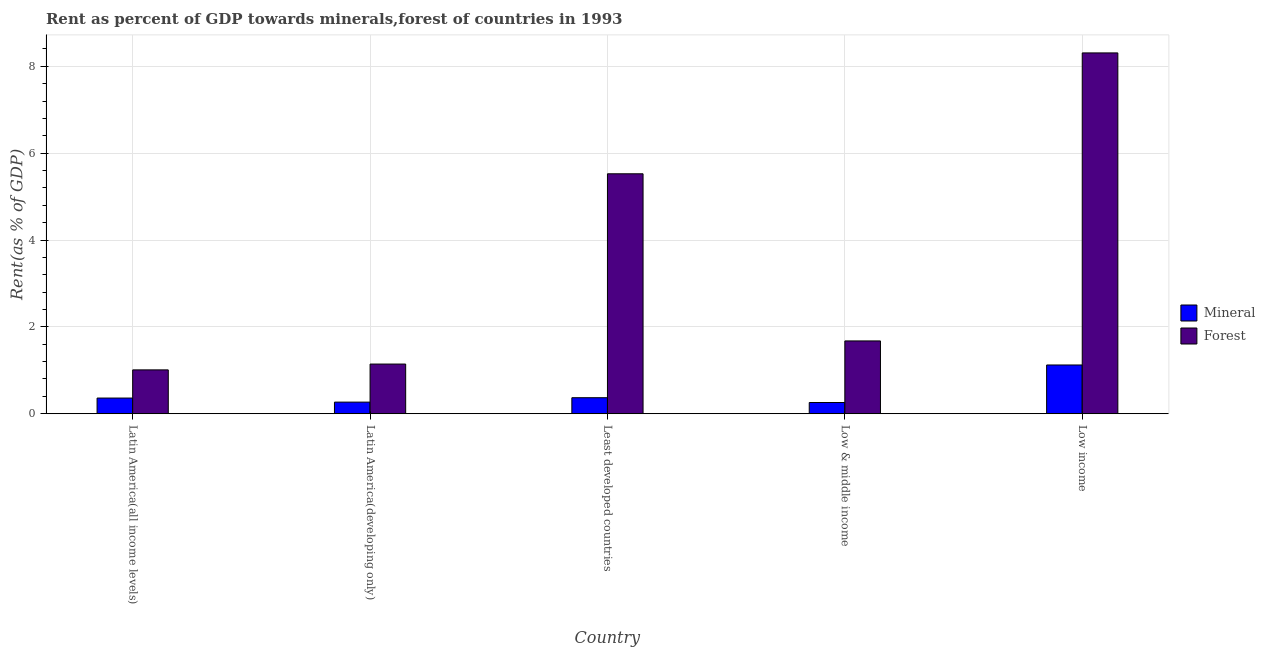How many different coloured bars are there?
Your answer should be very brief. 2. How many groups of bars are there?
Ensure brevity in your answer.  5. Are the number of bars on each tick of the X-axis equal?
Give a very brief answer. Yes. How many bars are there on the 1st tick from the left?
Your response must be concise. 2. How many bars are there on the 5th tick from the right?
Keep it short and to the point. 2. What is the label of the 3rd group of bars from the left?
Give a very brief answer. Least developed countries. In how many cases, is the number of bars for a given country not equal to the number of legend labels?
Provide a succinct answer. 0. What is the forest rent in Latin America(developing only)?
Your response must be concise. 1.14. Across all countries, what is the maximum mineral rent?
Provide a succinct answer. 1.12. Across all countries, what is the minimum forest rent?
Provide a short and direct response. 1.01. In which country was the forest rent minimum?
Provide a short and direct response. Latin America(all income levels). What is the total forest rent in the graph?
Provide a short and direct response. 17.66. What is the difference between the mineral rent in Latin America(all income levels) and that in Low & middle income?
Give a very brief answer. 0.1. What is the difference between the forest rent in Latin America(developing only) and the mineral rent in Low & middle income?
Provide a succinct answer. 0.89. What is the average forest rent per country?
Your response must be concise. 3.53. What is the difference between the forest rent and mineral rent in Low income?
Provide a succinct answer. 7.18. In how many countries, is the mineral rent greater than 0.4 %?
Provide a succinct answer. 1. What is the ratio of the forest rent in Latin America(all income levels) to that in Low & middle income?
Provide a short and direct response. 0.6. What is the difference between the highest and the second highest forest rent?
Your answer should be compact. 2.78. What is the difference between the highest and the lowest mineral rent?
Give a very brief answer. 0.86. In how many countries, is the mineral rent greater than the average mineral rent taken over all countries?
Make the answer very short. 1. Is the sum of the forest rent in Latin America(developing only) and Least developed countries greater than the maximum mineral rent across all countries?
Provide a short and direct response. Yes. What does the 2nd bar from the left in Least developed countries represents?
Your response must be concise. Forest. What does the 1st bar from the right in Low income represents?
Your response must be concise. Forest. How many countries are there in the graph?
Offer a very short reply. 5. Are the values on the major ticks of Y-axis written in scientific E-notation?
Your response must be concise. No. Does the graph contain any zero values?
Your response must be concise. No. Does the graph contain grids?
Keep it short and to the point. Yes. How many legend labels are there?
Keep it short and to the point. 2. What is the title of the graph?
Keep it short and to the point. Rent as percent of GDP towards minerals,forest of countries in 1993. Does "Stunting" appear as one of the legend labels in the graph?
Ensure brevity in your answer.  No. What is the label or title of the Y-axis?
Provide a short and direct response. Rent(as % of GDP). What is the Rent(as % of GDP) of Mineral in Latin America(all income levels)?
Offer a very short reply. 0.36. What is the Rent(as % of GDP) of Forest in Latin America(all income levels)?
Ensure brevity in your answer.  1.01. What is the Rent(as % of GDP) of Mineral in Latin America(developing only)?
Provide a short and direct response. 0.27. What is the Rent(as % of GDP) in Forest in Latin America(developing only)?
Offer a terse response. 1.14. What is the Rent(as % of GDP) in Mineral in Least developed countries?
Give a very brief answer. 0.37. What is the Rent(as % of GDP) of Forest in Least developed countries?
Offer a very short reply. 5.52. What is the Rent(as % of GDP) in Mineral in Low & middle income?
Give a very brief answer. 0.26. What is the Rent(as % of GDP) of Forest in Low & middle income?
Offer a very short reply. 1.68. What is the Rent(as % of GDP) in Mineral in Low income?
Offer a terse response. 1.12. What is the Rent(as % of GDP) in Forest in Low income?
Offer a very short reply. 8.31. Across all countries, what is the maximum Rent(as % of GDP) of Mineral?
Offer a very short reply. 1.12. Across all countries, what is the maximum Rent(as % of GDP) of Forest?
Keep it short and to the point. 8.31. Across all countries, what is the minimum Rent(as % of GDP) in Mineral?
Your answer should be very brief. 0.26. Across all countries, what is the minimum Rent(as % of GDP) in Forest?
Your answer should be very brief. 1.01. What is the total Rent(as % of GDP) in Mineral in the graph?
Ensure brevity in your answer.  2.38. What is the total Rent(as % of GDP) in Forest in the graph?
Provide a succinct answer. 17.66. What is the difference between the Rent(as % of GDP) in Mineral in Latin America(all income levels) and that in Latin America(developing only)?
Your answer should be very brief. 0.09. What is the difference between the Rent(as % of GDP) of Forest in Latin America(all income levels) and that in Latin America(developing only)?
Give a very brief answer. -0.13. What is the difference between the Rent(as % of GDP) in Mineral in Latin America(all income levels) and that in Least developed countries?
Keep it short and to the point. -0.01. What is the difference between the Rent(as % of GDP) of Forest in Latin America(all income levels) and that in Least developed countries?
Provide a succinct answer. -4.51. What is the difference between the Rent(as % of GDP) of Mineral in Latin America(all income levels) and that in Low & middle income?
Ensure brevity in your answer.  0.1. What is the difference between the Rent(as % of GDP) in Forest in Latin America(all income levels) and that in Low & middle income?
Ensure brevity in your answer.  -0.67. What is the difference between the Rent(as % of GDP) of Mineral in Latin America(all income levels) and that in Low income?
Offer a very short reply. -0.76. What is the difference between the Rent(as % of GDP) of Forest in Latin America(all income levels) and that in Low income?
Your answer should be very brief. -7.3. What is the difference between the Rent(as % of GDP) of Mineral in Latin America(developing only) and that in Least developed countries?
Provide a short and direct response. -0.1. What is the difference between the Rent(as % of GDP) in Forest in Latin America(developing only) and that in Least developed countries?
Keep it short and to the point. -4.38. What is the difference between the Rent(as % of GDP) in Mineral in Latin America(developing only) and that in Low & middle income?
Your response must be concise. 0.01. What is the difference between the Rent(as % of GDP) in Forest in Latin America(developing only) and that in Low & middle income?
Offer a very short reply. -0.53. What is the difference between the Rent(as % of GDP) of Mineral in Latin America(developing only) and that in Low income?
Your answer should be very brief. -0.86. What is the difference between the Rent(as % of GDP) of Forest in Latin America(developing only) and that in Low income?
Give a very brief answer. -7.16. What is the difference between the Rent(as % of GDP) of Mineral in Least developed countries and that in Low & middle income?
Offer a terse response. 0.11. What is the difference between the Rent(as % of GDP) of Forest in Least developed countries and that in Low & middle income?
Ensure brevity in your answer.  3.85. What is the difference between the Rent(as % of GDP) in Mineral in Least developed countries and that in Low income?
Ensure brevity in your answer.  -0.75. What is the difference between the Rent(as % of GDP) of Forest in Least developed countries and that in Low income?
Offer a terse response. -2.78. What is the difference between the Rent(as % of GDP) of Mineral in Low & middle income and that in Low income?
Make the answer very short. -0.86. What is the difference between the Rent(as % of GDP) in Forest in Low & middle income and that in Low income?
Provide a succinct answer. -6.63. What is the difference between the Rent(as % of GDP) in Mineral in Latin America(all income levels) and the Rent(as % of GDP) in Forest in Latin America(developing only)?
Offer a very short reply. -0.78. What is the difference between the Rent(as % of GDP) of Mineral in Latin America(all income levels) and the Rent(as % of GDP) of Forest in Least developed countries?
Keep it short and to the point. -5.16. What is the difference between the Rent(as % of GDP) in Mineral in Latin America(all income levels) and the Rent(as % of GDP) in Forest in Low & middle income?
Your answer should be compact. -1.32. What is the difference between the Rent(as % of GDP) in Mineral in Latin America(all income levels) and the Rent(as % of GDP) in Forest in Low income?
Your answer should be compact. -7.95. What is the difference between the Rent(as % of GDP) of Mineral in Latin America(developing only) and the Rent(as % of GDP) of Forest in Least developed countries?
Your response must be concise. -5.26. What is the difference between the Rent(as % of GDP) in Mineral in Latin America(developing only) and the Rent(as % of GDP) in Forest in Low & middle income?
Make the answer very short. -1.41. What is the difference between the Rent(as % of GDP) of Mineral in Latin America(developing only) and the Rent(as % of GDP) of Forest in Low income?
Offer a very short reply. -8.04. What is the difference between the Rent(as % of GDP) in Mineral in Least developed countries and the Rent(as % of GDP) in Forest in Low & middle income?
Offer a very short reply. -1.31. What is the difference between the Rent(as % of GDP) of Mineral in Least developed countries and the Rent(as % of GDP) of Forest in Low income?
Offer a very short reply. -7.94. What is the difference between the Rent(as % of GDP) in Mineral in Low & middle income and the Rent(as % of GDP) in Forest in Low income?
Your answer should be compact. -8.05. What is the average Rent(as % of GDP) of Mineral per country?
Your response must be concise. 0.48. What is the average Rent(as % of GDP) in Forest per country?
Make the answer very short. 3.53. What is the difference between the Rent(as % of GDP) in Mineral and Rent(as % of GDP) in Forest in Latin America(all income levels)?
Your answer should be compact. -0.65. What is the difference between the Rent(as % of GDP) of Mineral and Rent(as % of GDP) of Forest in Latin America(developing only)?
Ensure brevity in your answer.  -0.88. What is the difference between the Rent(as % of GDP) in Mineral and Rent(as % of GDP) in Forest in Least developed countries?
Your answer should be compact. -5.16. What is the difference between the Rent(as % of GDP) in Mineral and Rent(as % of GDP) in Forest in Low & middle income?
Offer a terse response. -1.42. What is the difference between the Rent(as % of GDP) in Mineral and Rent(as % of GDP) in Forest in Low income?
Make the answer very short. -7.18. What is the ratio of the Rent(as % of GDP) in Mineral in Latin America(all income levels) to that in Latin America(developing only)?
Provide a succinct answer. 1.35. What is the ratio of the Rent(as % of GDP) of Forest in Latin America(all income levels) to that in Latin America(developing only)?
Ensure brevity in your answer.  0.88. What is the ratio of the Rent(as % of GDP) in Mineral in Latin America(all income levels) to that in Least developed countries?
Make the answer very short. 0.98. What is the ratio of the Rent(as % of GDP) in Forest in Latin America(all income levels) to that in Least developed countries?
Give a very brief answer. 0.18. What is the ratio of the Rent(as % of GDP) in Mineral in Latin America(all income levels) to that in Low & middle income?
Give a very brief answer. 1.4. What is the ratio of the Rent(as % of GDP) in Forest in Latin America(all income levels) to that in Low & middle income?
Offer a terse response. 0.6. What is the ratio of the Rent(as % of GDP) of Mineral in Latin America(all income levels) to that in Low income?
Your response must be concise. 0.32. What is the ratio of the Rent(as % of GDP) in Forest in Latin America(all income levels) to that in Low income?
Offer a terse response. 0.12. What is the ratio of the Rent(as % of GDP) of Mineral in Latin America(developing only) to that in Least developed countries?
Offer a very short reply. 0.72. What is the ratio of the Rent(as % of GDP) in Forest in Latin America(developing only) to that in Least developed countries?
Your answer should be compact. 0.21. What is the ratio of the Rent(as % of GDP) of Mineral in Latin America(developing only) to that in Low & middle income?
Offer a very short reply. 1.03. What is the ratio of the Rent(as % of GDP) in Forest in Latin America(developing only) to that in Low & middle income?
Provide a short and direct response. 0.68. What is the ratio of the Rent(as % of GDP) in Mineral in Latin America(developing only) to that in Low income?
Provide a short and direct response. 0.24. What is the ratio of the Rent(as % of GDP) in Forest in Latin America(developing only) to that in Low income?
Your response must be concise. 0.14. What is the ratio of the Rent(as % of GDP) of Mineral in Least developed countries to that in Low & middle income?
Give a very brief answer. 1.43. What is the ratio of the Rent(as % of GDP) of Forest in Least developed countries to that in Low & middle income?
Give a very brief answer. 3.3. What is the ratio of the Rent(as % of GDP) of Mineral in Least developed countries to that in Low income?
Offer a terse response. 0.33. What is the ratio of the Rent(as % of GDP) of Forest in Least developed countries to that in Low income?
Your response must be concise. 0.67. What is the ratio of the Rent(as % of GDP) in Mineral in Low & middle income to that in Low income?
Provide a succinct answer. 0.23. What is the ratio of the Rent(as % of GDP) of Forest in Low & middle income to that in Low income?
Make the answer very short. 0.2. What is the difference between the highest and the second highest Rent(as % of GDP) in Mineral?
Provide a short and direct response. 0.75. What is the difference between the highest and the second highest Rent(as % of GDP) in Forest?
Provide a succinct answer. 2.78. What is the difference between the highest and the lowest Rent(as % of GDP) in Mineral?
Your answer should be compact. 0.86. What is the difference between the highest and the lowest Rent(as % of GDP) in Forest?
Ensure brevity in your answer.  7.3. 